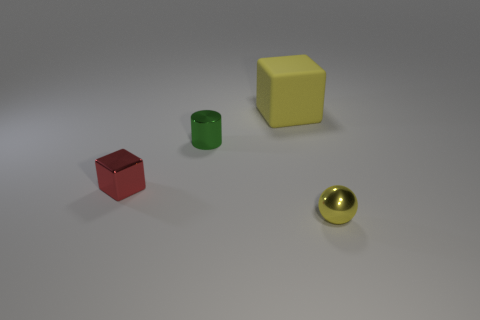Add 3 tiny yellow balls. How many objects exist? 7 Subtract all cylinders. How many objects are left? 3 Subtract all small red metallic cubes. Subtract all large cubes. How many objects are left? 2 Add 4 yellow spheres. How many yellow spheres are left? 5 Add 3 tiny yellow spheres. How many tiny yellow spheres exist? 4 Subtract 0 red cylinders. How many objects are left? 4 